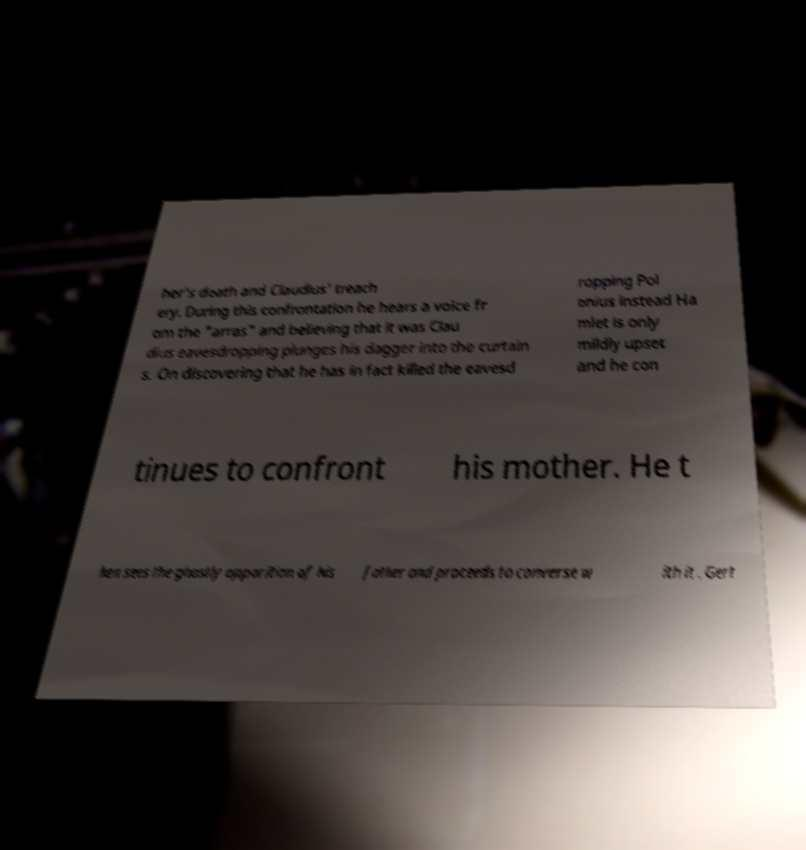For documentation purposes, I need the text within this image transcribed. Could you provide that? her's death and Claudius' treach ery. During this confrontation he hears a voice fr om the "arras" and believing that it was Clau dius eavesdropping plunges his dagger into the curtain s. On discovering that he has in fact killed the eavesd ropping Pol onius instead Ha mlet is only mildly upset and he con tinues to confront his mother. He t hen sees the ghostly apparition of his father and proceeds to converse w ith it . Gert 